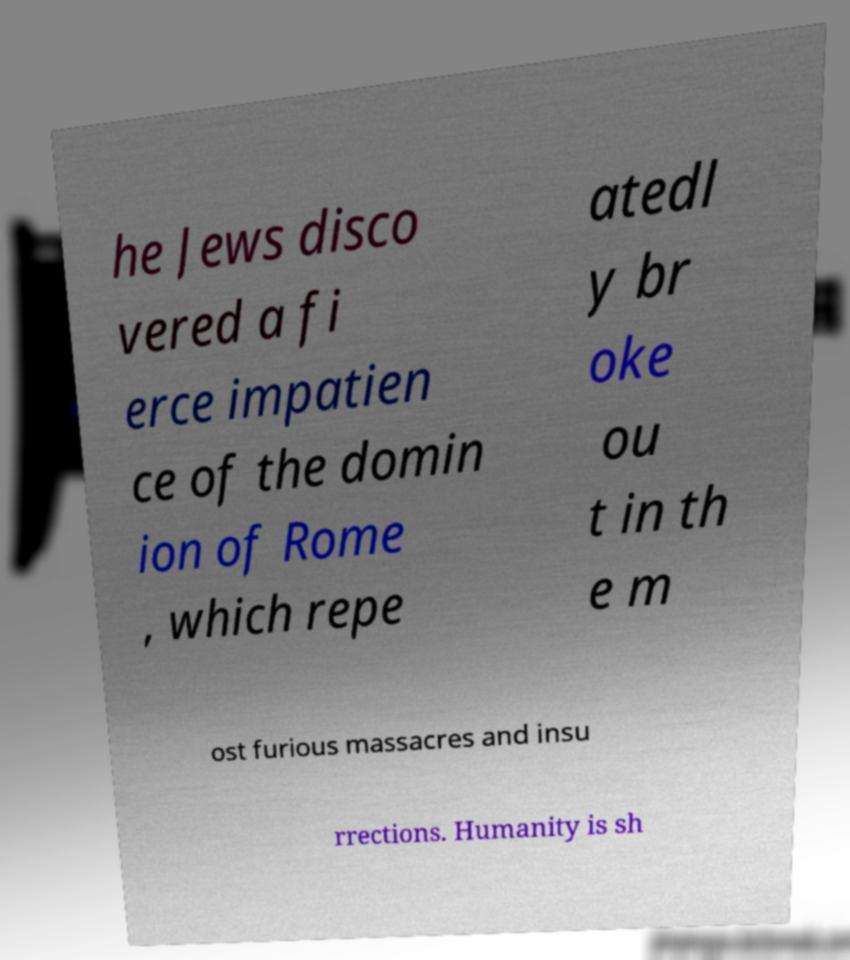Please read and relay the text visible in this image. What does it say? he Jews disco vered a fi erce impatien ce of the domin ion of Rome , which repe atedl y br oke ou t in th e m ost furious massacres and insu rrections. Humanity is sh 